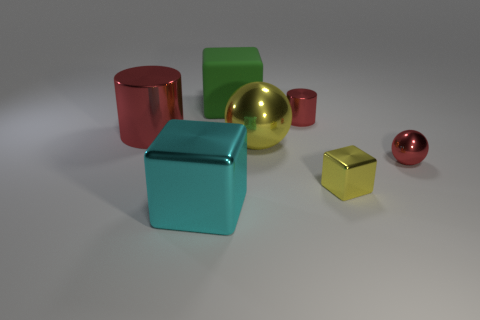Are there more big yellow objects behind the rubber object than things right of the small yellow metal block?
Ensure brevity in your answer.  No. There is a cube that is behind the big sphere; what is its color?
Your response must be concise. Green. There is a tiny red metallic object that is behind the tiny red metallic sphere; is it the same shape as the tiny red metallic thing that is in front of the large red object?
Your answer should be compact. No. Is there a red matte block of the same size as the red metal ball?
Make the answer very short. No. There is a large object that is behind the small red cylinder; what is its material?
Make the answer very short. Rubber. Is the cylinder to the left of the large matte object made of the same material as the small yellow object?
Keep it short and to the point. Yes. Are there any small yellow shiny cylinders?
Keep it short and to the point. No. There is a large cube that is the same material as the large sphere; what color is it?
Provide a succinct answer. Cyan. What color is the big cube that is in front of the tiny red thing that is behind the shiny ball to the right of the tiny yellow block?
Give a very brief answer. Cyan. Is the size of the red metal ball the same as the red shiny cylinder to the left of the big cyan metallic block?
Offer a very short reply. No. 